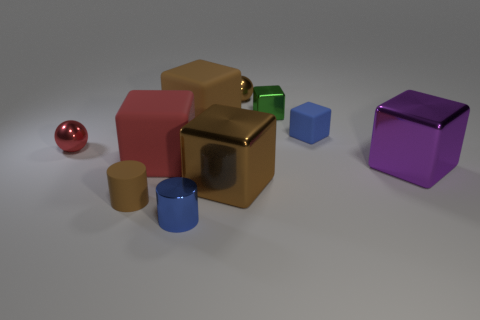Subtract 2 blocks. How many blocks are left? 4 Subtract all large purple shiny blocks. How many blocks are left? 5 Subtract all brown cubes. How many cubes are left? 4 Subtract all brown cubes. Subtract all yellow cylinders. How many cubes are left? 4 Subtract all spheres. How many objects are left? 8 Subtract 0 gray balls. How many objects are left? 10 Subtract all shiny blocks. Subtract all tiny yellow metal blocks. How many objects are left? 7 Add 3 brown objects. How many brown objects are left? 7 Add 1 tiny rubber blocks. How many tiny rubber blocks exist? 2 